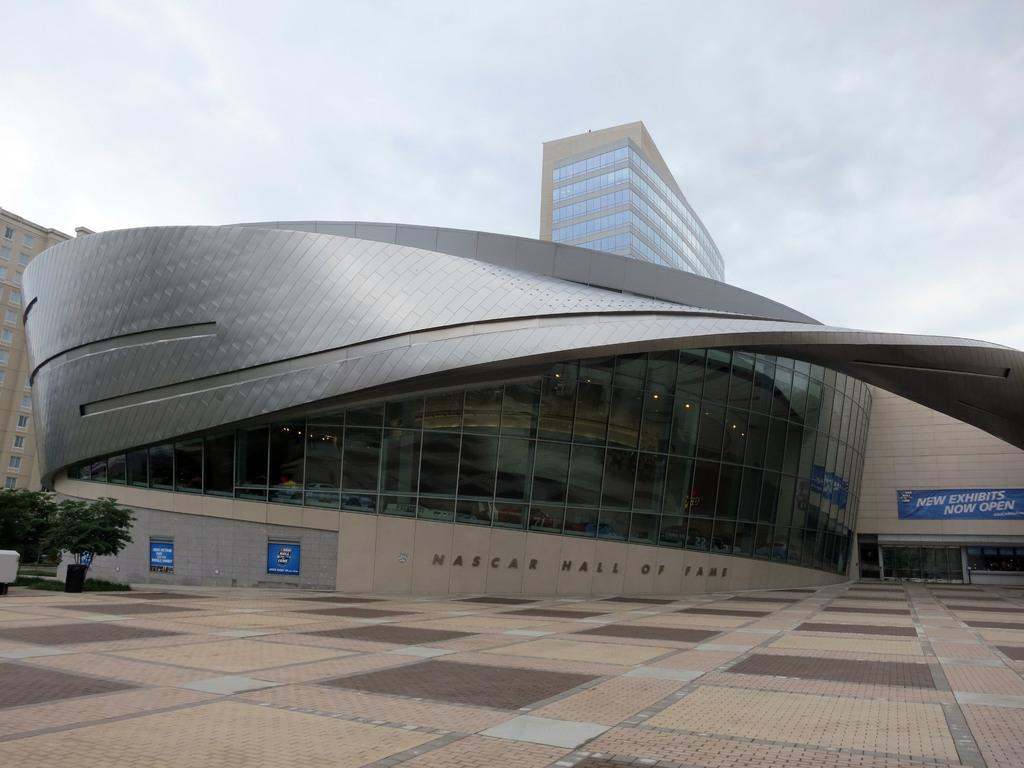<image>
Offer a succinct explanation of the picture presented. New Exhibits now open which is a new building 